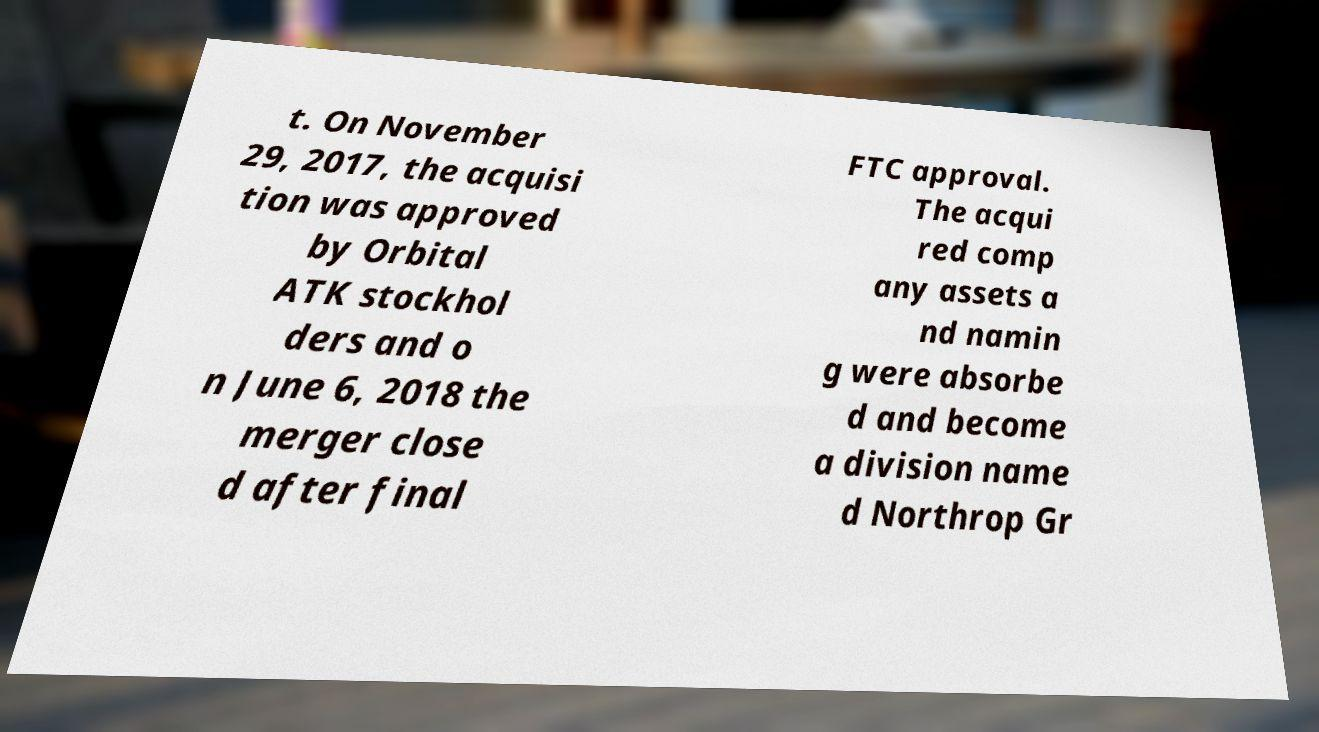I need the written content from this picture converted into text. Can you do that? t. On November 29, 2017, the acquisi tion was approved by Orbital ATK stockhol ders and o n June 6, 2018 the merger close d after final FTC approval. The acqui red comp any assets a nd namin g were absorbe d and become a division name d Northrop Gr 